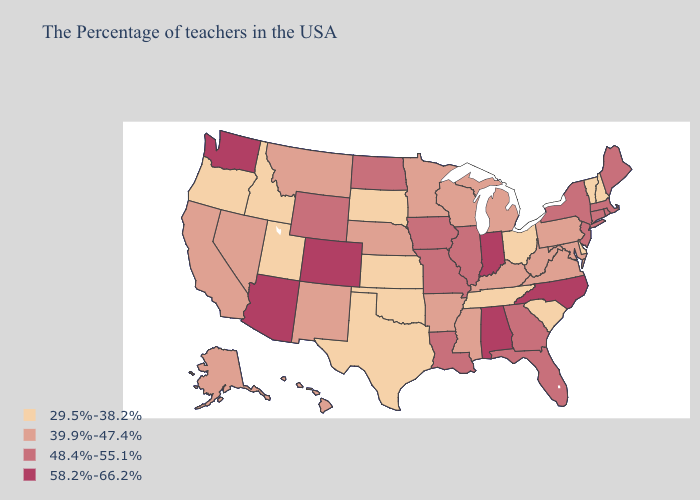What is the value of Washington?
Keep it brief. 58.2%-66.2%. Does Delaware have the highest value in the USA?
Keep it brief. No. Does Massachusetts have the lowest value in the Northeast?
Keep it brief. No. What is the value of Louisiana?
Write a very short answer. 48.4%-55.1%. Does Alabama have the highest value in the USA?
Short answer required. Yes. What is the highest value in the Northeast ?
Give a very brief answer. 48.4%-55.1%. Is the legend a continuous bar?
Short answer required. No. Which states have the highest value in the USA?
Concise answer only. North Carolina, Indiana, Alabama, Colorado, Arizona, Washington. Name the states that have a value in the range 29.5%-38.2%?
Concise answer only. New Hampshire, Vermont, Delaware, South Carolina, Ohio, Tennessee, Kansas, Oklahoma, Texas, South Dakota, Utah, Idaho, Oregon. Does South Carolina have the highest value in the USA?
Concise answer only. No. Name the states that have a value in the range 58.2%-66.2%?
Quick response, please. North Carolina, Indiana, Alabama, Colorado, Arizona, Washington. Which states have the lowest value in the Northeast?
Give a very brief answer. New Hampshire, Vermont. Does the map have missing data?
Give a very brief answer. No. Does Arkansas have a higher value than New York?
Write a very short answer. No. Does Idaho have the lowest value in the USA?
Give a very brief answer. Yes. 